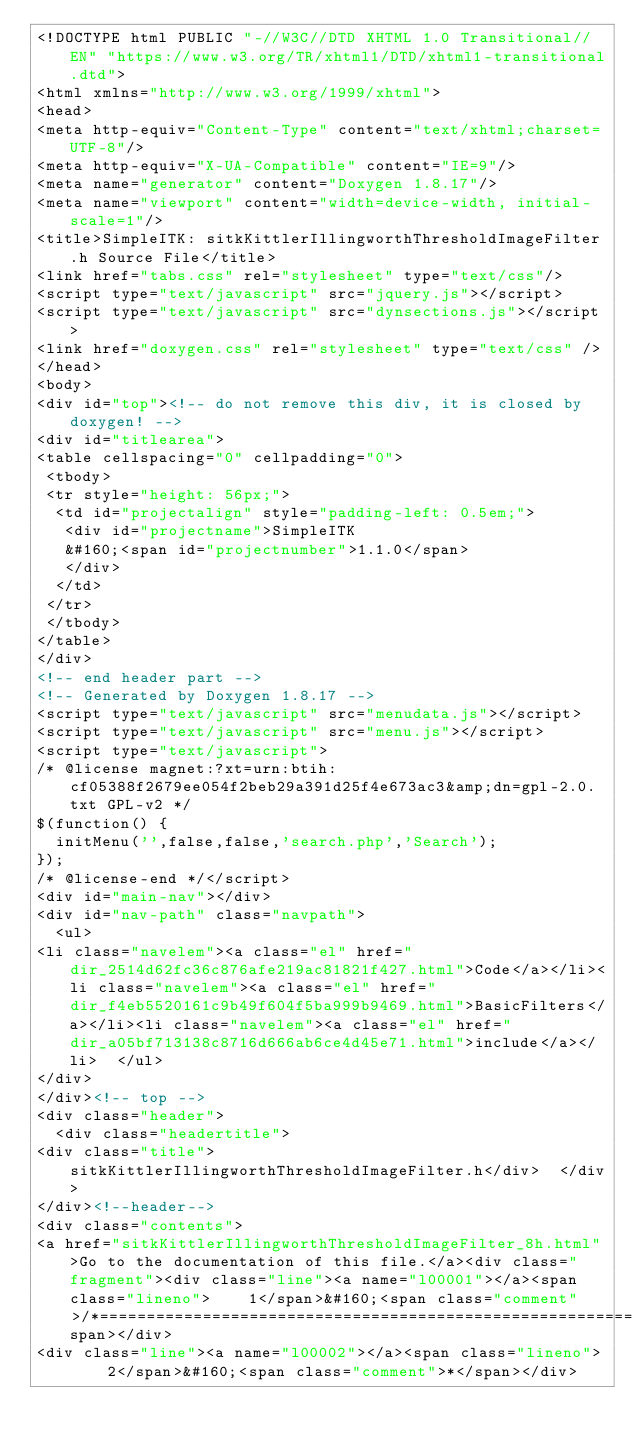<code> <loc_0><loc_0><loc_500><loc_500><_HTML_><!DOCTYPE html PUBLIC "-//W3C//DTD XHTML 1.0 Transitional//EN" "https://www.w3.org/TR/xhtml1/DTD/xhtml1-transitional.dtd">
<html xmlns="http://www.w3.org/1999/xhtml">
<head>
<meta http-equiv="Content-Type" content="text/xhtml;charset=UTF-8"/>
<meta http-equiv="X-UA-Compatible" content="IE=9"/>
<meta name="generator" content="Doxygen 1.8.17"/>
<meta name="viewport" content="width=device-width, initial-scale=1"/>
<title>SimpleITK: sitkKittlerIllingworthThresholdImageFilter.h Source File</title>
<link href="tabs.css" rel="stylesheet" type="text/css"/>
<script type="text/javascript" src="jquery.js"></script>
<script type="text/javascript" src="dynsections.js"></script>
<link href="doxygen.css" rel="stylesheet" type="text/css" />
</head>
<body>
<div id="top"><!-- do not remove this div, it is closed by doxygen! -->
<div id="titlearea">
<table cellspacing="0" cellpadding="0">
 <tbody>
 <tr style="height: 56px;">
  <td id="projectalign" style="padding-left: 0.5em;">
   <div id="projectname">SimpleITK
   &#160;<span id="projectnumber">1.1.0</span>
   </div>
  </td>
 </tr>
 </tbody>
</table>
</div>
<!-- end header part -->
<!-- Generated by Doxygen 1.8.17 -->
<script type="text/javascript" src="menudata.js"></script>
<script type="text/javascript" src="menu.js"></script>
<script type="text/javascript">
/* @license magnet:?xt=urn:btih:cf05388f2679ee054f2beb29a391d25f4e673ac3&amp;dn=gpl-2.0.txt GPL-v2 */
$(function() {
  initMenu('',false,false,'search.php','Search');
});
/* @license-end */</script>
<div id="main-nav"></div>
<div id="nav-path" class="navpath">
  <ul>
<li class="navelem"><a class="el" href="dir_2514d62fc36c876afe219ac81821f427.html">Code</a></li><li class="navelem"><a class="el" href="dir_f4eb5520161c9b49f604f5ba999b9469.html">BasicFilters</a></li><li class="navelem"><a class="el" href="dir_a05bf713138c8716d666ab6ce4d45e71.html">include</a></li>  </ul>
</div>
</div><!-- top -->
<div class="header">
  <div class="headertitle">
<div class="title">sitkKittlerIllingworthThresholdImageFilter.h</div>  </div>
</div><!--header-->
<div class="contents">
<a href="sitkKittlerIllingworthThresholdImageFilter_8h.html">Go to the documentation of this file.</a><div class="fragment"><div class="line"><a name="l00001"></a><span class="lineno">    1</span>&#160;<span class="comment">/*=========================================================================</span></div>
<div class="line"><a name="l00002"></a><span class="lineno">    2</span>&#160;<span class="comment">*</span></div></code> 